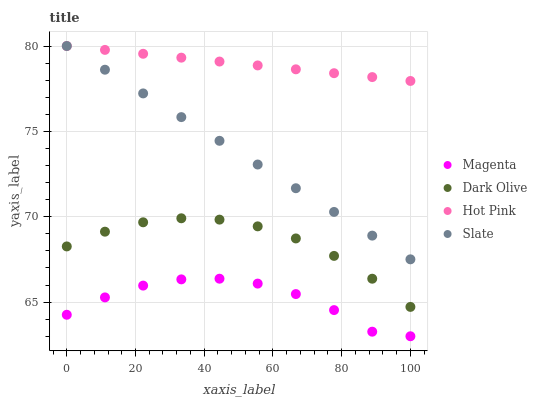Does Magenta have the minimum area under the curve?
Answer yes or no. Yes. Does Hot Pink have the maximum area under the curve?
Answer yes or no. Yes. Does Dark Olive have the minimum area under the curve?
Answer yes or no. No. Does Dark Olive have the maximum area under the curve?
Answer yes or no. No. Is Slate the smoothest?
Answer yes or no. Yes. Is Magenta the roughest?
Answer yes or no. Yes. Is Dark Olive the smoothest?
Answer yes or no. No. Is Dark Olive the roughest?
Answer yes or no. No. Does Magenta have the lowest value?
Answer yes or no. Yes. Does Dark Olive have the lowest value?
Answer yes or no. No. Does Hot Pink have the highest value?
Answer yes or no. Yes. Does Dark Olive have the highest value?
Answer yes or no. No. Is Magenta less than Dark Olive?
Answer yes or no. Yes. Is Hot Pink greater than Dark Olive?
Answer yes or no. Yes. Does Hot Pink intersect Slate?
Answer yes or no. Yes. Is Hot Pink less than Slate?
Answer yes or no. No. Is Hot Pink greater than Slate?
Answer yes or no. No. Does Magenta intersect Dark Olive?
Answer yes or no. No. 